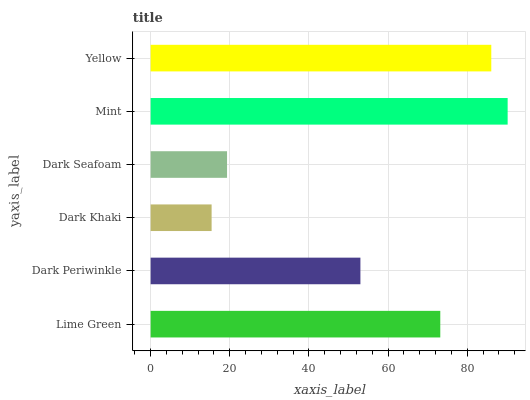Is Dark Khaki the minimum?
Answer yes or no. Yes. Is Mint the maximum?
Answer yes or no. Yes. Is Dark Periwinkle the minimum?
Answer yes or no. No. Is Dark Periwinkle the maximum?
Answer yes or no. No. Is Lime Green greater than Dark Periwinkle?
Answer yes or no. Yes. Is Dark Periwinkle less than Lime Green?
Answer yes or no. Yes. Is Dark Periwinkle greater than Lime Green?
Answer yes or no. No. Is Lime Green less than Dark Periwinkle?
Answer yes or no. No. Is Lime Green the high median?
Answer yes or no. Yes. Is Dark Periwinkle the low median?
Answer yes or no. Yes. Is Dark Khaki the high median?
Answer yes or no. No. Is Mint the low median?
Answer yes or no. No. 